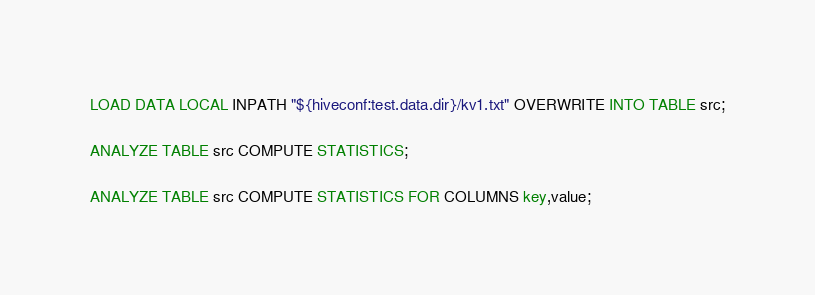<code> <loc_0><loc_0><loc_500><loc_500><_SQL_>
LOAD DATA LOCAL INPATH "${hiveconf:test.data.dir}/kv1.txt" OVERWRITE INTO TABLE src;

ANALYZE TABLE src COMPUTE STATISTICS;

ANALYZE TABLE src COMPUTE STATISTICS FOR COLUMNS key,value;
</code> 